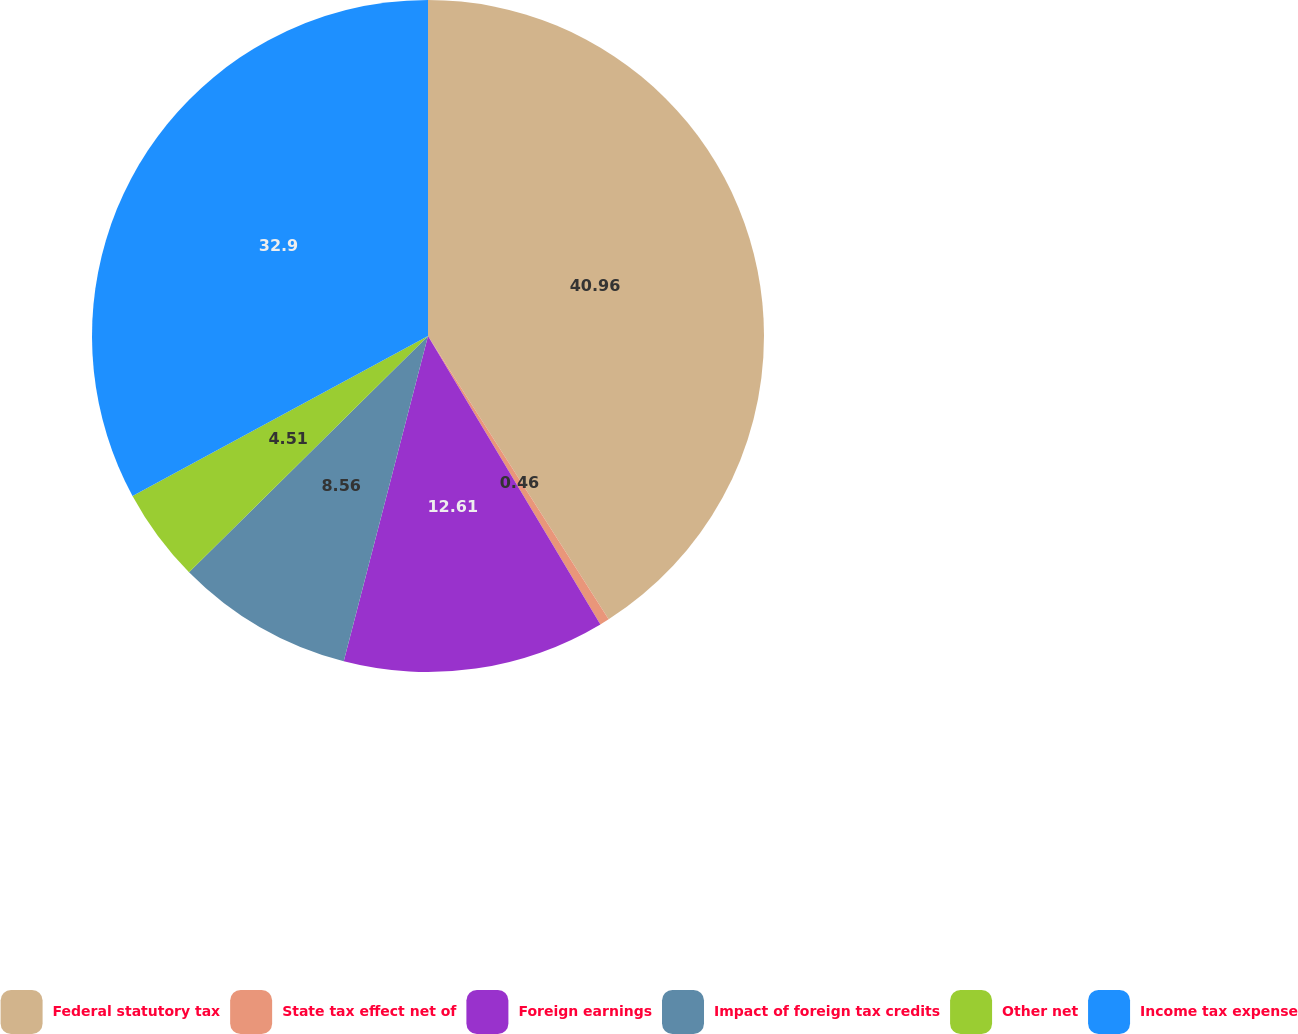Convert chart to OTSL. <chart><loc_0><loc_0><loc_500><loc_500><pie_chart><fcel>Federal statutory tax<fcel>State tax effect net of<fcel>Foreign earnings<fcel>Impact of foreign tax credits<fcel>Other net<fcel>Income tax expense<nl><fcel>40.97%<fcel>0.46%<fcel>12.61%<fcel>8.56%<fcel>4.51%<fcel>32.9%<nl></chart> 